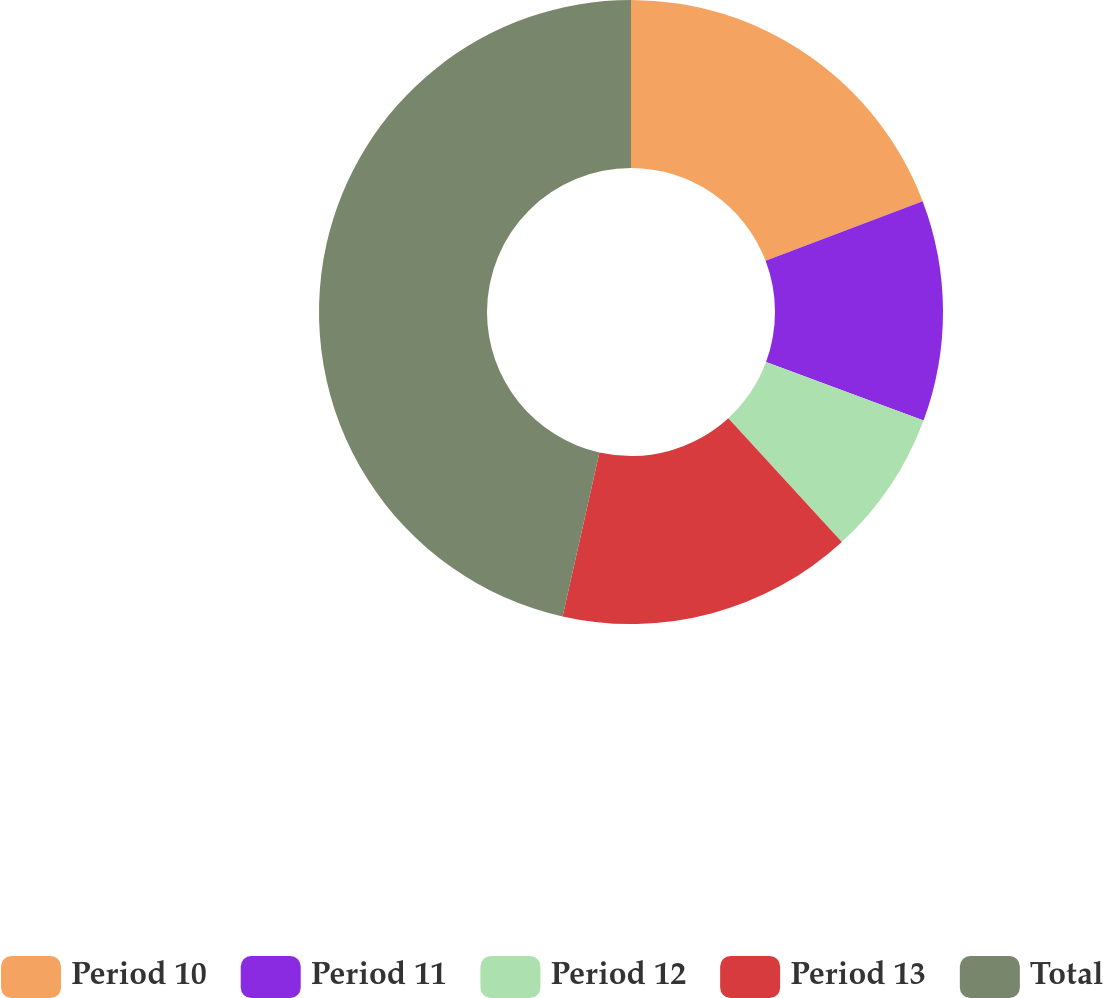<chart> <loc_0><loc_0><loc_500><loc_500><pie_chart><fcel>Period 10<fcel>Period 11<fcel>Period 12<fcel>Period 13<fcel>Total<nl><fcel>19.22%<fcel>11.43%<fcel>7.54%<fcel>15.33%<fcel>46.48%<nl></chart> 